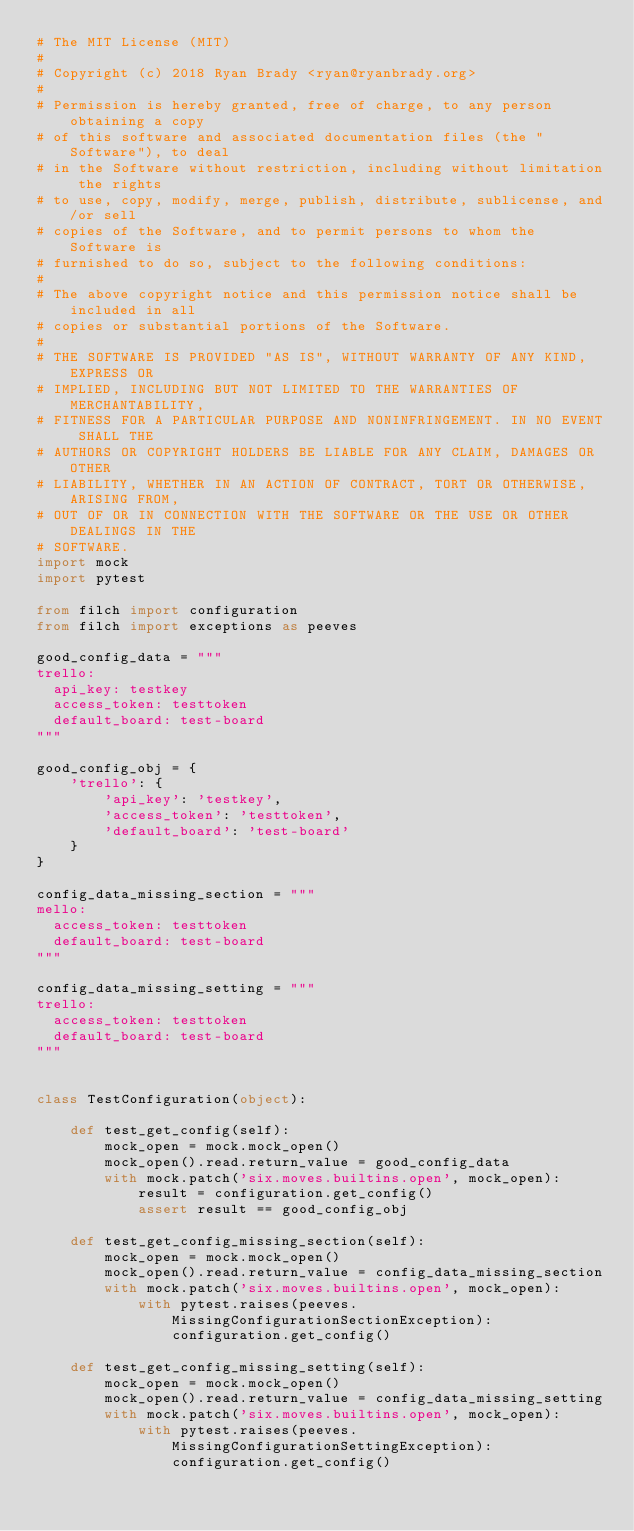<code> <loc_0><loc_0><loc_500><loc_500><_Python_># The MIT License (MIT)
#
# Copyright (c) 2018 Ryan Brady <ryan@ryanbrady.org>
#
# Permission is hereby granted, free of charge, to any person obtaining a copy
# of this software and associated documentation files (the "Software"), to deal
# in the Software without restriction, including without limitation the rights
# to use, copy, modify, merge, publish, distribute, sublicense, and/or sell
# copies of the Software, and to permit persons to whom the Software is
# furnished to do so, subject to the following conditions:
#
# The above copyright notice and this permission notice shall be included in all
# copies or substantial portions of the Software.
#
# THE SOFTWARE IS PROVIDED "AS IS", WITHOUT WARRANTY OF ANY KIND, EXPRESS OR
# IMPLIED, INCLUDING BUT NOT LIMITED TO THE WARRANTIES OF MERCHANTABILITY,
# FITNESS FOR A PARTICULAR PURPOSE AND NONINFRINGEMENT. IN NO EVENT SHALL THE
# AUTHORS OR COPYRIGHT HOLDERS BE LIABLE FOR ANY CLAIM, DAMAGES OR OTHER
# LIABILITY, WHETHER IN AN ACTION OF CONTRACT, TORT OR OTHERWISE, ARISING FROM,
# OUT OF OR IN CONNECTION WITH THE SOFTWARE OR THE USE OR OTHER DEALINGS IN THE
# SOFTWARE.
import mock
import pytest

from filch import configuration
from filch import exceptions as peeves

good_config_data = """
trello:
  api_key: testkey
  access_token: testtoken
  default_board: test-board
"""

good_config_obj = {
    'trello': {
        'api_key': 'testkey',
        'access_token': 'testtoken',
        'default_board': 'test-board'
    }
}

config_data_missing_section = """
mello:
  access_token: testtoken
  default_board: test-board
"""

config_data_missing_setting = """
trello:
  access_token: testtoken
  default_board: test-board
"""


class TestConfiguration(object):

    def test_get_config(self):
        mock_open = mock.mock_open()
        mock_open().read.return_value = good_config_data
        with mock.patch('six.moves.builtins.open', mock_open):
            result = configuration.get_config()
            assert result == good_config_obj

    def test_get_config_missing_section(self):
        mock_open = mock.mock_open()
        mock_open().read.return_value = config_data_missing_section
        with mock.patch('six.moves.builtins.open', mock_open):
            with pytest.raises(peeves.MissingConfigurationSectionException):
                configuration.get_config()

    def test_get_config_missing_setting(self):
        mock_open = mock.mock_open()
        mock_open().read.return_value = config_data_missing_setting
        with mock.patch('six.moves.builtins.open', mock_open):
            with pytest.raises(peeves.MissingConfigurationSettingException):
                configuration.get_config()
</code> 